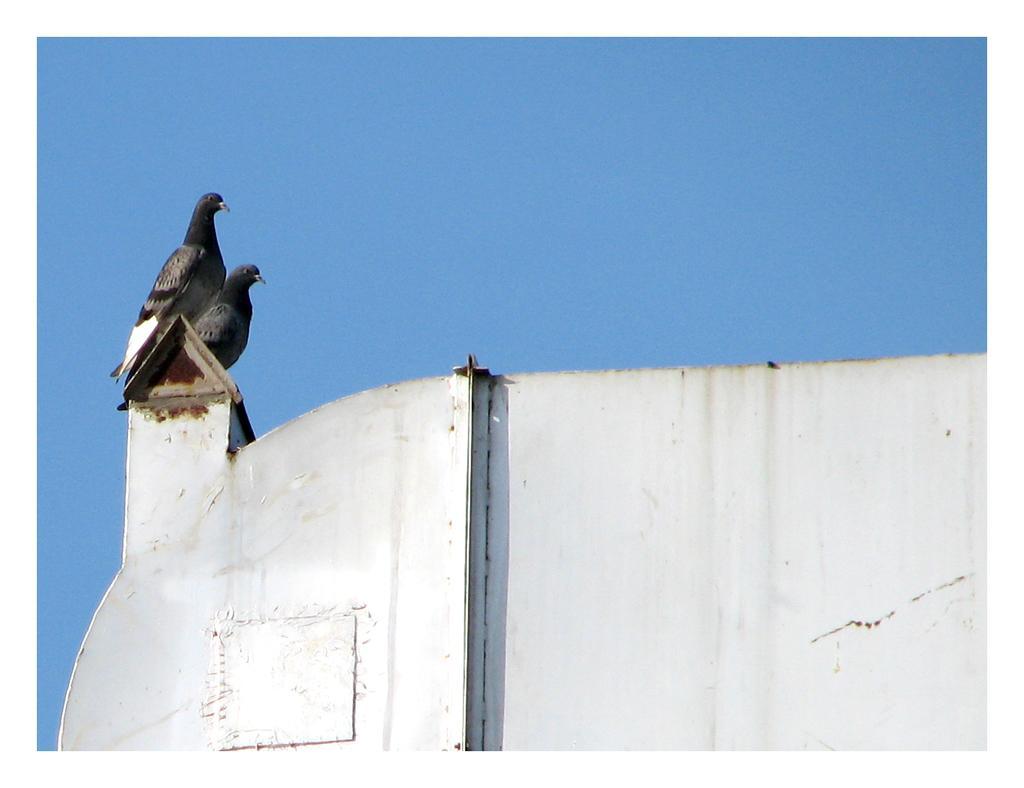In one or two sentences, can you explain what this image depicts? In this image we can see pigeons standing on the wall and sky in the background. 